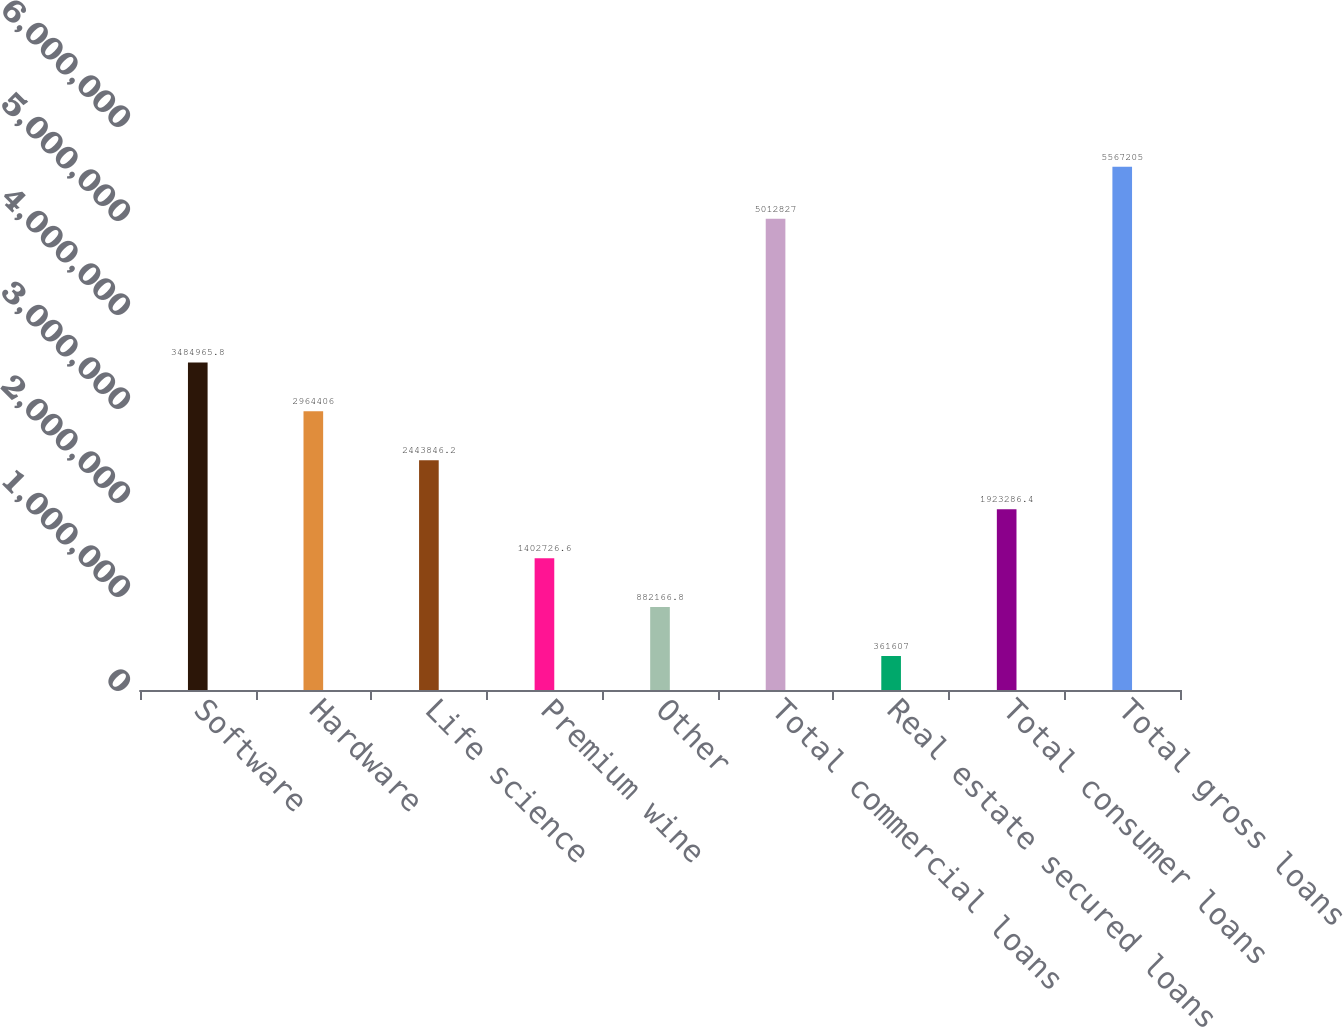Convert chart to OTSL. <chart><loc_0><loc_0><loc_500><loc_500><bar_chart><fcel>Software<fcel>Hardware<fcel>Life science<fcel>Premium wine<fcel>Other<fcel>Total commercial loans<fcel>Real estate secured loans<fcel>Total consumer loans<fcel>Total gross loans<nl><fcel>3.48497e+06<fcel>2.96441e+06<fcel>2.44385e+06<fcel>1.40273e+06<fcel>882167<fcel>5.01283e+06<fcel>361607<fcel>1.92329e+06<fcel>5.5672e+06<nl></chart> 